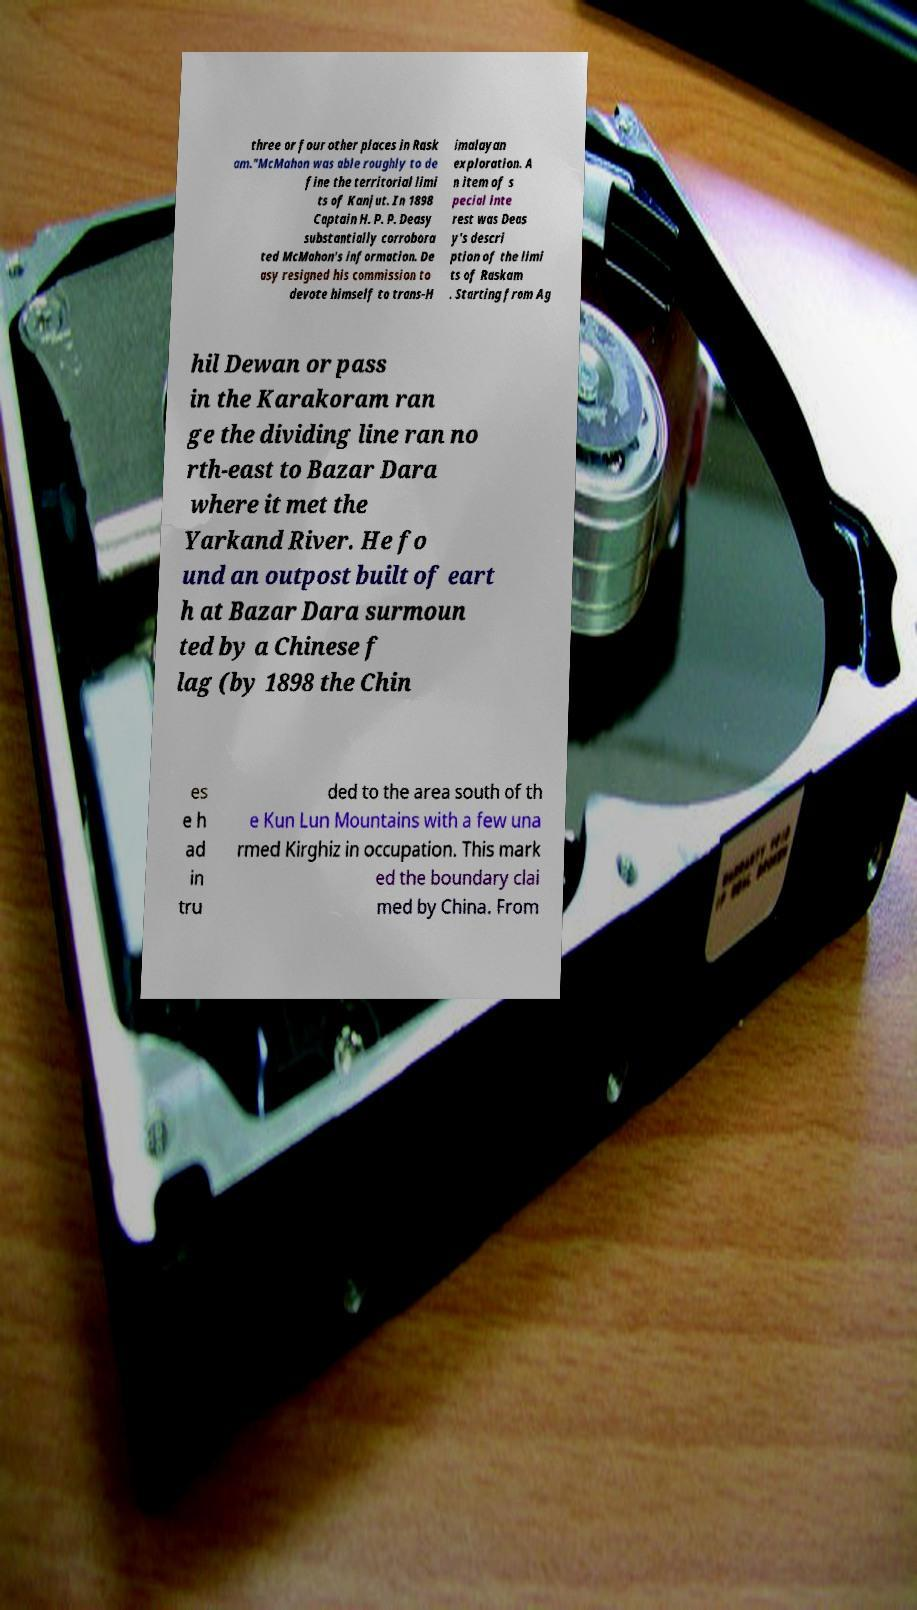I need the written content from this picture converted into text. Can you do that? three or four other places in Rask am."McMahon was able roughly to de fine the territorial limi ts of Kanjut. In 1898 Captain H. P. P. Deasy substantially corrobora ted McMahon's information. De asy resigned his commission to devote himself to trans-H imalayan exploration. A n item of s pecial inte rest was Deas y's descri ption of the limi ts of Raskam . Starting from Ag hil Dewan or pass in the Karakoram ran ge the dividing line ran no rth-east to Bazar Dara where it met the Yarkand River. He fo und an outpost built of eart h at Bazar Dara surmoun ted by a Chinese f lag (by 1898 the Chin es e h ad in tru ded to the area south of th e Kun Lun Mountains with a few una rmed Kirghiz in occupation. This mark ed the boundary clai med by China. From 